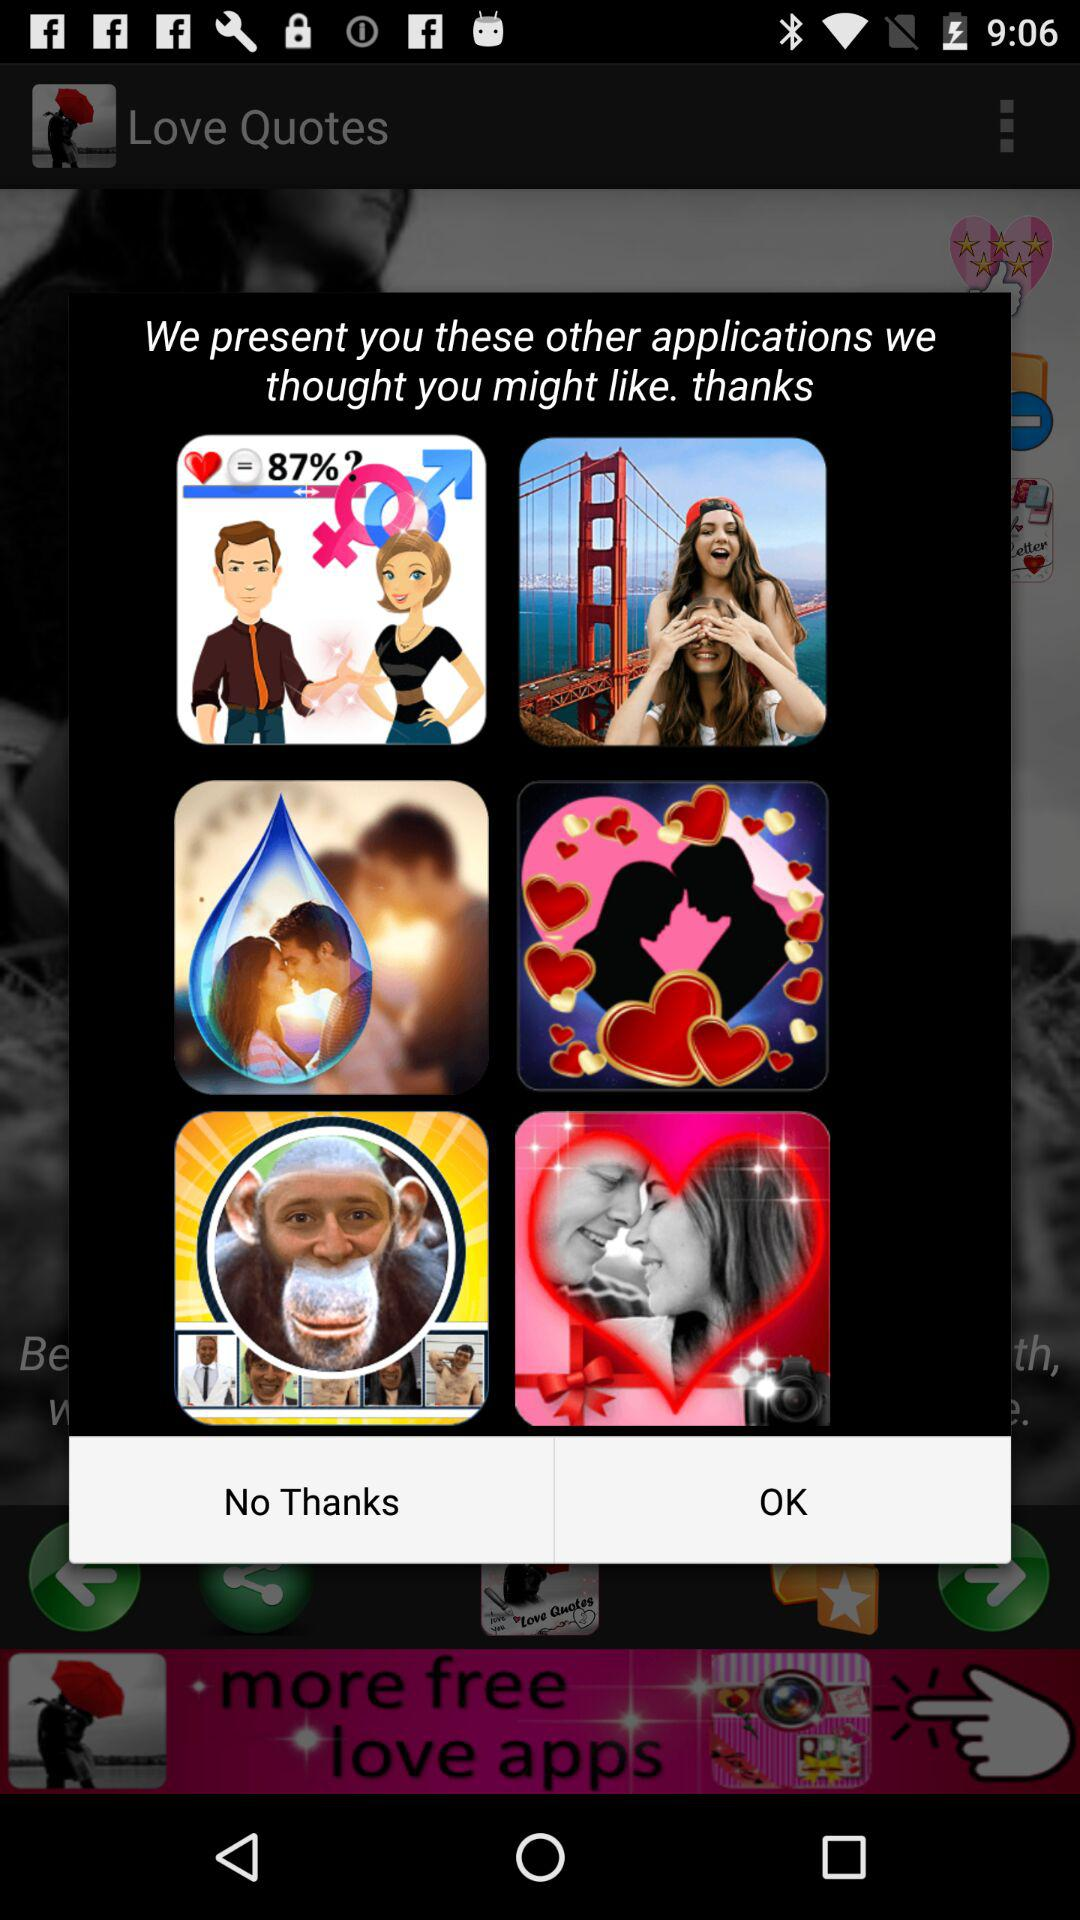What is the name of the application? The name of the application is "Love Quotes". 